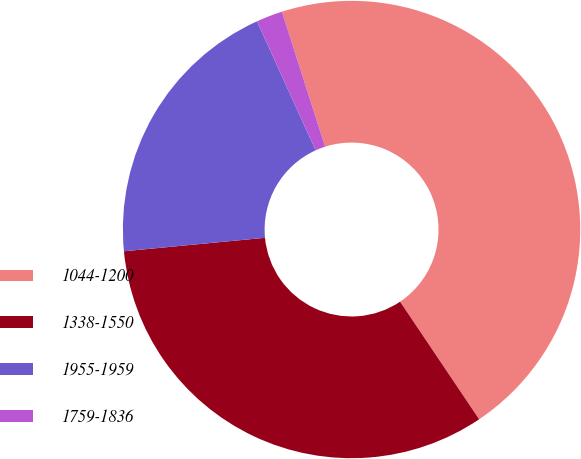Convert chart to OTSL. <chart><loc_0><loc_0><loc_500><loc_500><pie_chart><fcel>1044-1200<fcel>1338-1550<fcel>1955-1959<fcel>1759-1836<nl><fcel>45.5%<fcel>32.9%<fcel>19.73%<fcel>1.86%<nl></chart> 